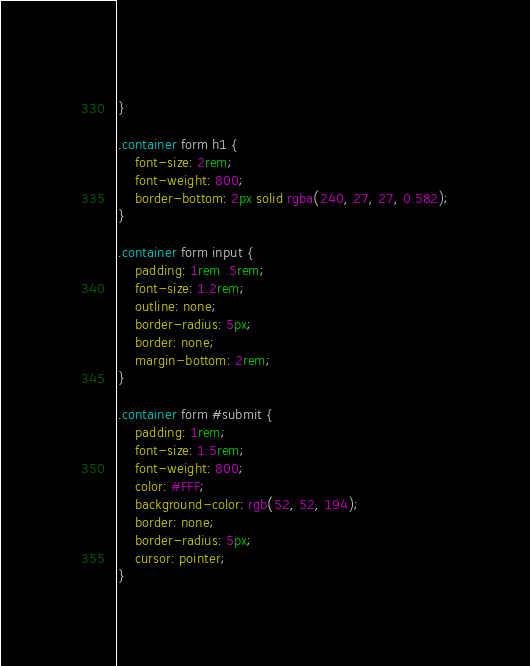Convert code to text. <code><loc_0><loc_0><loc_500><loc_500><_CSS_>    
}

.container form h1 {
    font-size: 2rem;
    font-weight: 800;
    border-bottom: 2px solid rgba(240, 27, 27, 0.582);
}

.container form input {
    padding: 1rem .5rem;
    font-size: 1.2rem;
    outline: none;
    border-radius: 5px;
    border: none;
    margin-bottom: 2rem;
}

.container form #submit {
    padding: 1rem;
    font-size: 1.5rem;
    font-weight: 800;
    color: #FFF;
    background-color: rgb(52, 52, 194);
    border: none;
    border-radius: 5px;
    cursor: pointer;
}</code> 